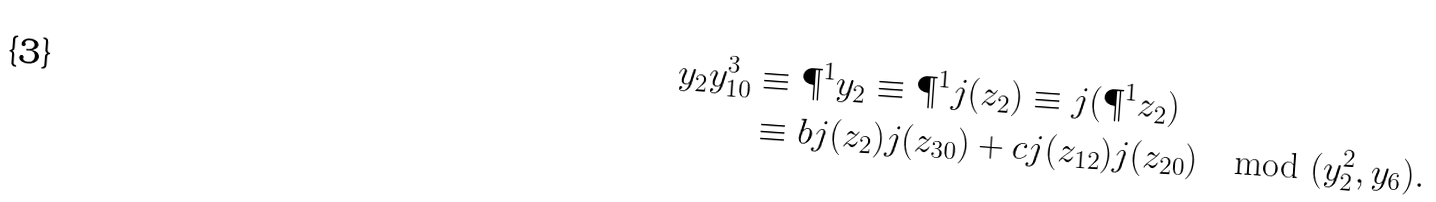<formula> <loc_0><loc_0><loc_500><loc_500>y _ { 2 } y _ { 1 0 } ^ { 3 } & \equiv \P ^ { 1 } y _ { 2 } \equiv \P ^ { 1 } j ( z _ { 2 } ) \equiv j ( \P ^ { 1 } z _ { 2 } ) \\ & \equiv b j ( z _ { 2 } ) j ( z _ { 3 0 } ) + c j ( z _ { 1 2 } ) j ( z _ { 2 0 } ) \mod { ( y _ { 2 } ^ { 2 } , y _ { 6 } ) } .</formula> 